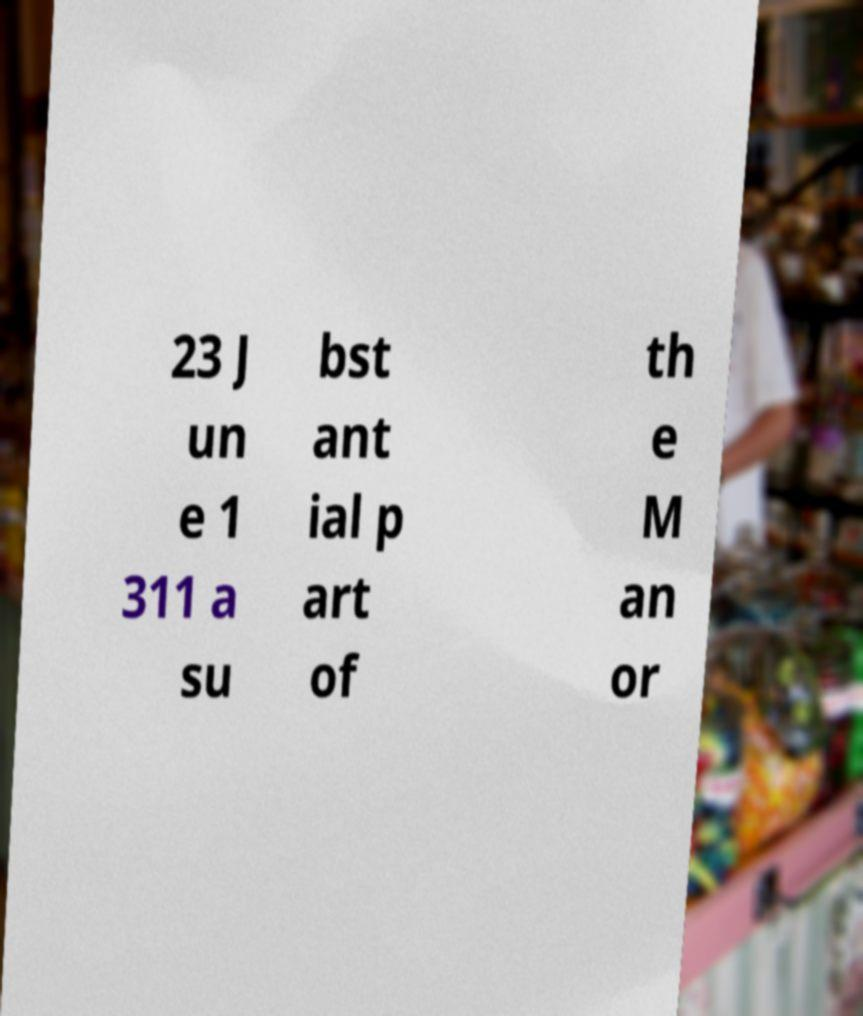I need the written content from this picture converted into text. Can you do that? 23 J un e 1 311 a su bst ant ial p art of th e M an or 